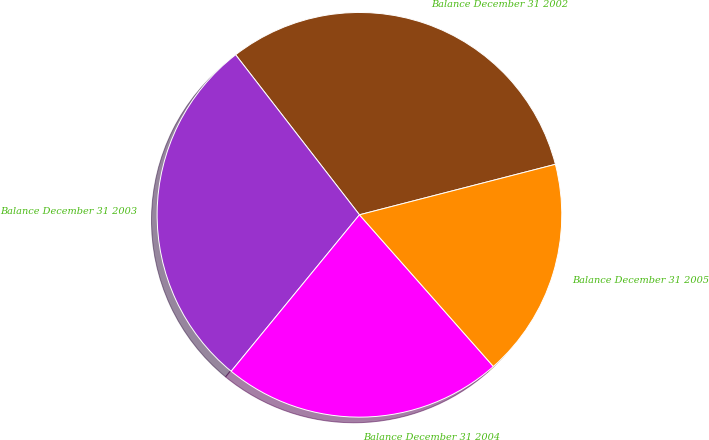<chart> <loc_0><loc_0><loc_500><loc_500><pie_chart><fcel>Balance December 31 2002<fcel>Balance December 31 2003<fcel>Balance December 31 2004<fcel>Balance December 31 2005<nl><fcel>31.47%<fcel>28.59%<fcel>22.44%<fcel>17.5%<nl></chart> 